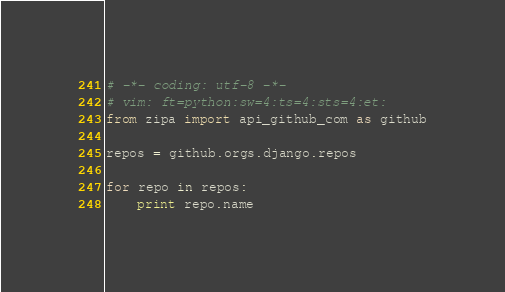Convert code to text. <code><loc_0><loc_0><loc_500><loc_500><_Python_># -*- coding: utf-8 -*-
# vim: ft=python:sw=4:ts=4:sts=4:et:
from zipa import api_github_com as github

repos = github.orgs.django.repos

for repo in repos:
    print repo.name
</code> 